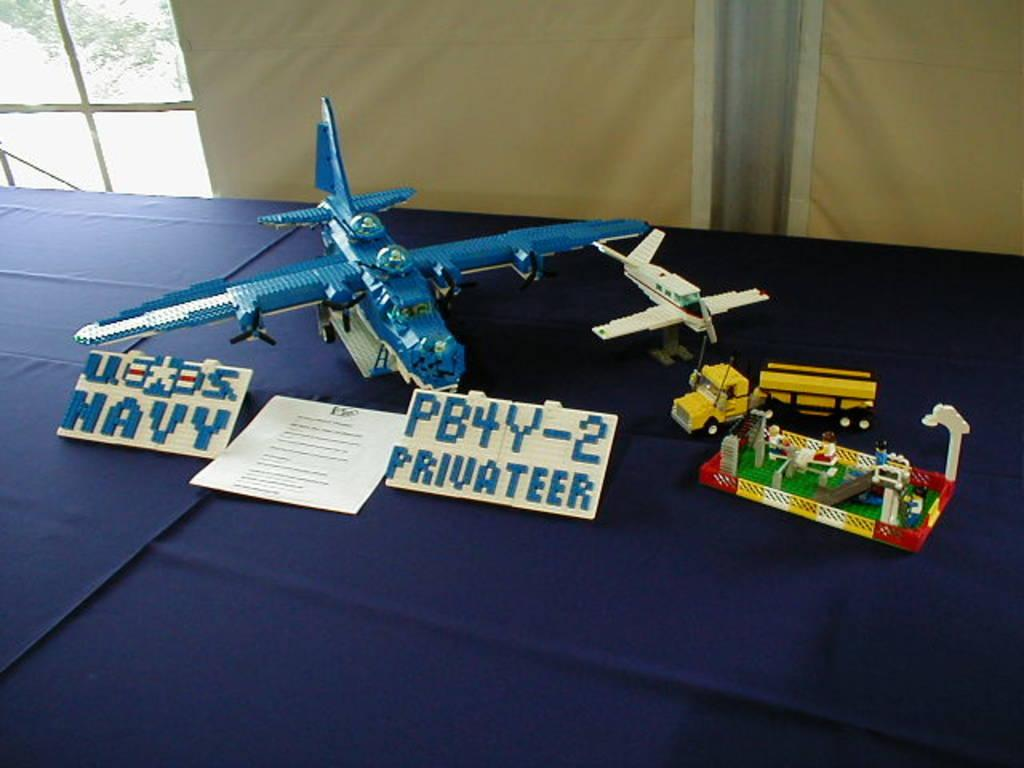What can be seen in the background of the image? There is a glass window and a blue cloth in the background of the image. What color is the cloth in the image? The cloth in the image is blue. What is placed on the blue cloth? There are toys, a paper note with some information, and boards on the blue cloth. Is there a balloon floating above the toys on the blue cloth? There is no balloon present in the image. What type of debt is mentioned on the paper note on the blue cloth? There is no mention of debt on the paper note in the image, as it contains some information but not about debt. 